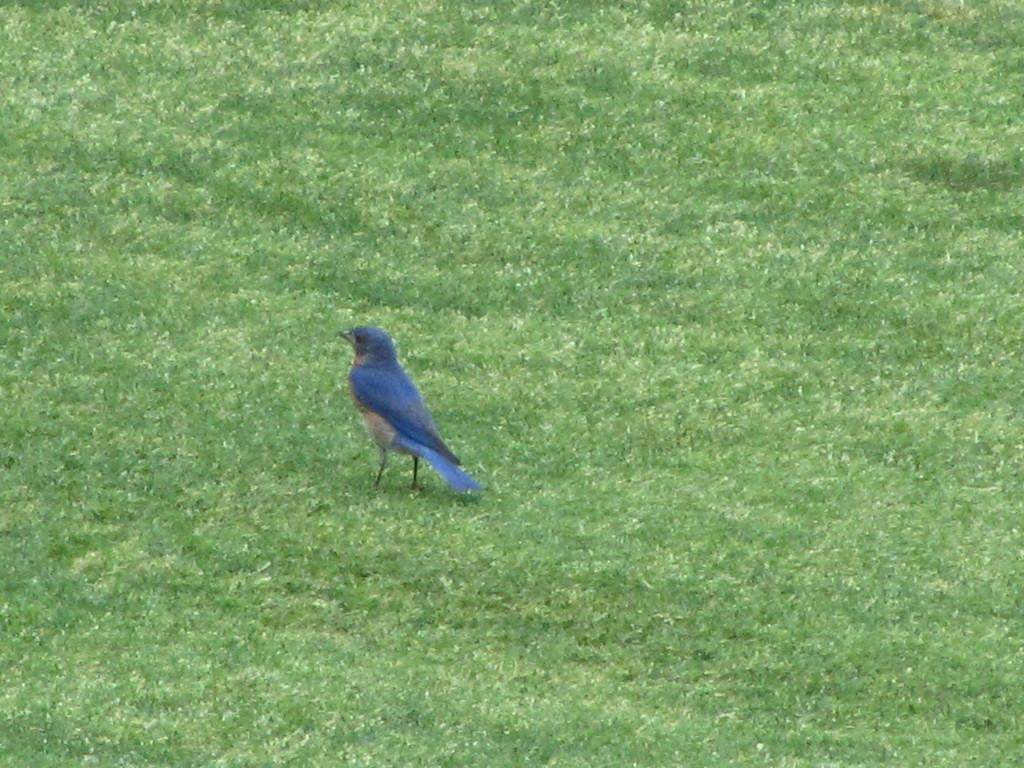What type of animal can be seen in the image? There is a bird in the image. Where is the bird located in the image? The bird is standing on the ground. What type of skirt is the bird wearing in the image? Birds do not wear skirts, so this detail cannot be found in the image. 